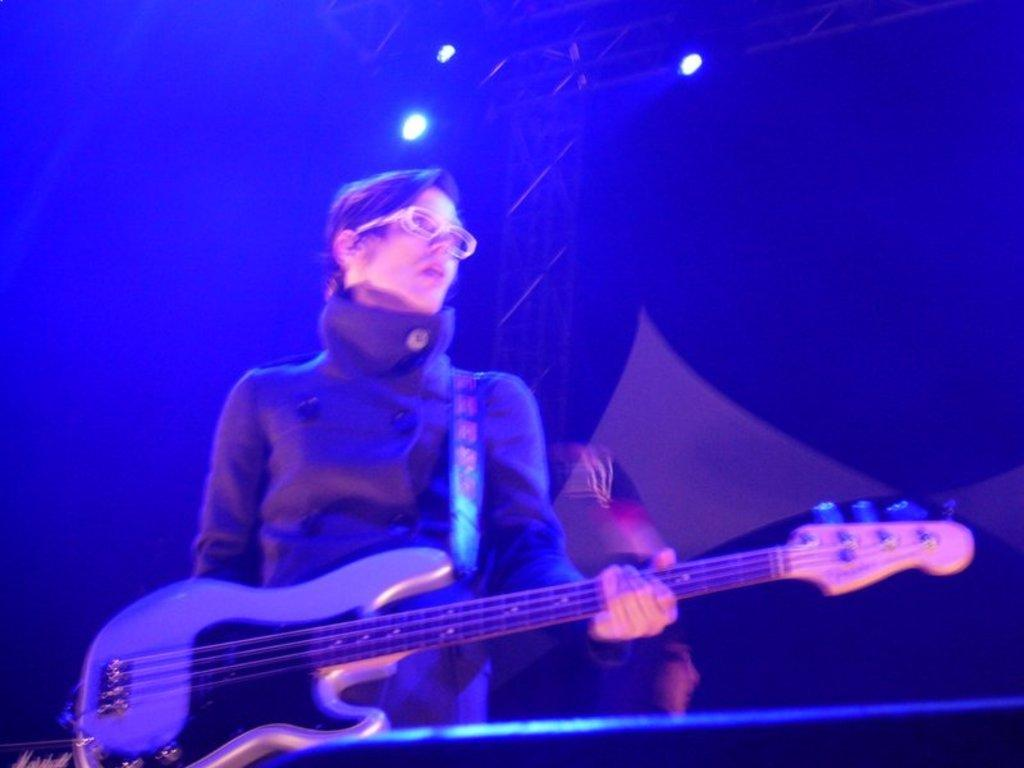What is the main subject of the image? There is a person in the image. What is the person doing in the image? The person is standing and playing a guitar. What objects are present in the image besides the person? There is a speaker at the front of the image and a light at the top of the image. What type of activity is the person having trouble with in the image? There is no indication in the image that the person is having trouble with any activity. 